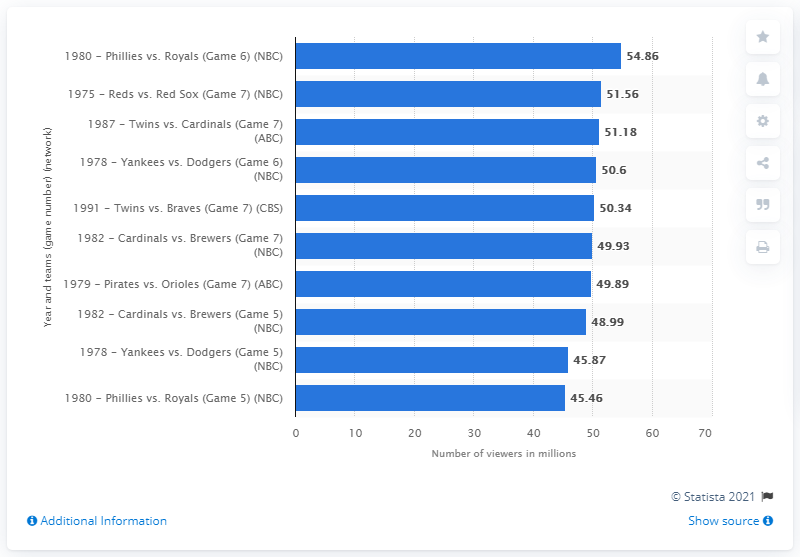Specify some key components in this picture. The number of people who watched Game 7 of the 1975 World Series between the Cincinnati Reds and the Boston Red Sox is 51.56. 